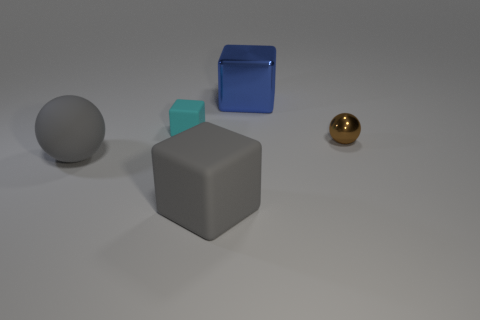Does the cyan matte object have the same size as the brown object?
Your answer should be very brief. Yes. Are there an equal number of rubber spheres that are in front of the big rubber ball and blocks?
Your response must be concise. No. There is a cube that is in front of the small rubber block; is there a large gray rubber block in front of it?
Keep it short and to the point. No. How big is the matte block in front of the gray matte object to the left of the matte cube in front of the small cyan block?
Your response must be concise. Large. What material is the block on the left side of the gray object in front of the large gray rubber sphere?
Give a very brief answer. Rubber. Is there a small brown metal thing that has the same shape as the large blue object?
Give a very brief answer. No. There is a small rubber object; what shape is it?
Keep it short and to the point. Cube. What is the material of the ball in front of the shiny object in front of the large object behind the tiny brown metallic sphere?
Make the answer very short. Rubber. Are there more blue metal things that are in front of the tiny brown object than gray things?
Your response must be concise. No. There is a object that is the same size as the cyan block; what material is it?
Give a very brief answer. Metal. 